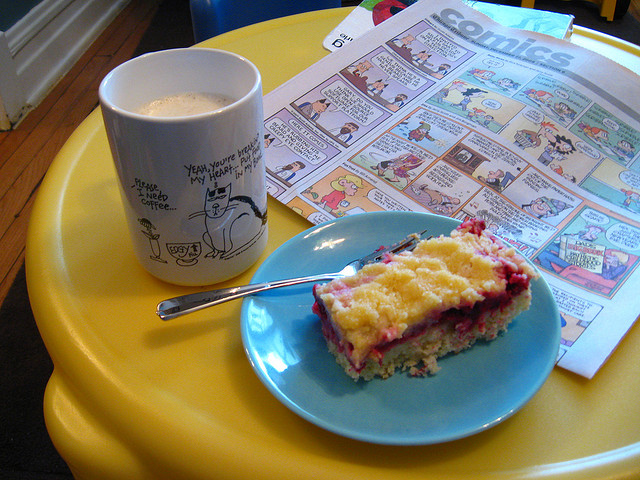<image>What kind of ball is on the coffee cup? There is no ball on the coffee cup. What is in the bowl? There is no bowl in the image. However, if there was a bowl, it could contain cake, pastry or coffee. What kind of ball is on the coffee cup? I don't know what kind of ball is on the coffee cup. There seems to be no ball on it. What is in the bowl? There is no bowl in the image. 